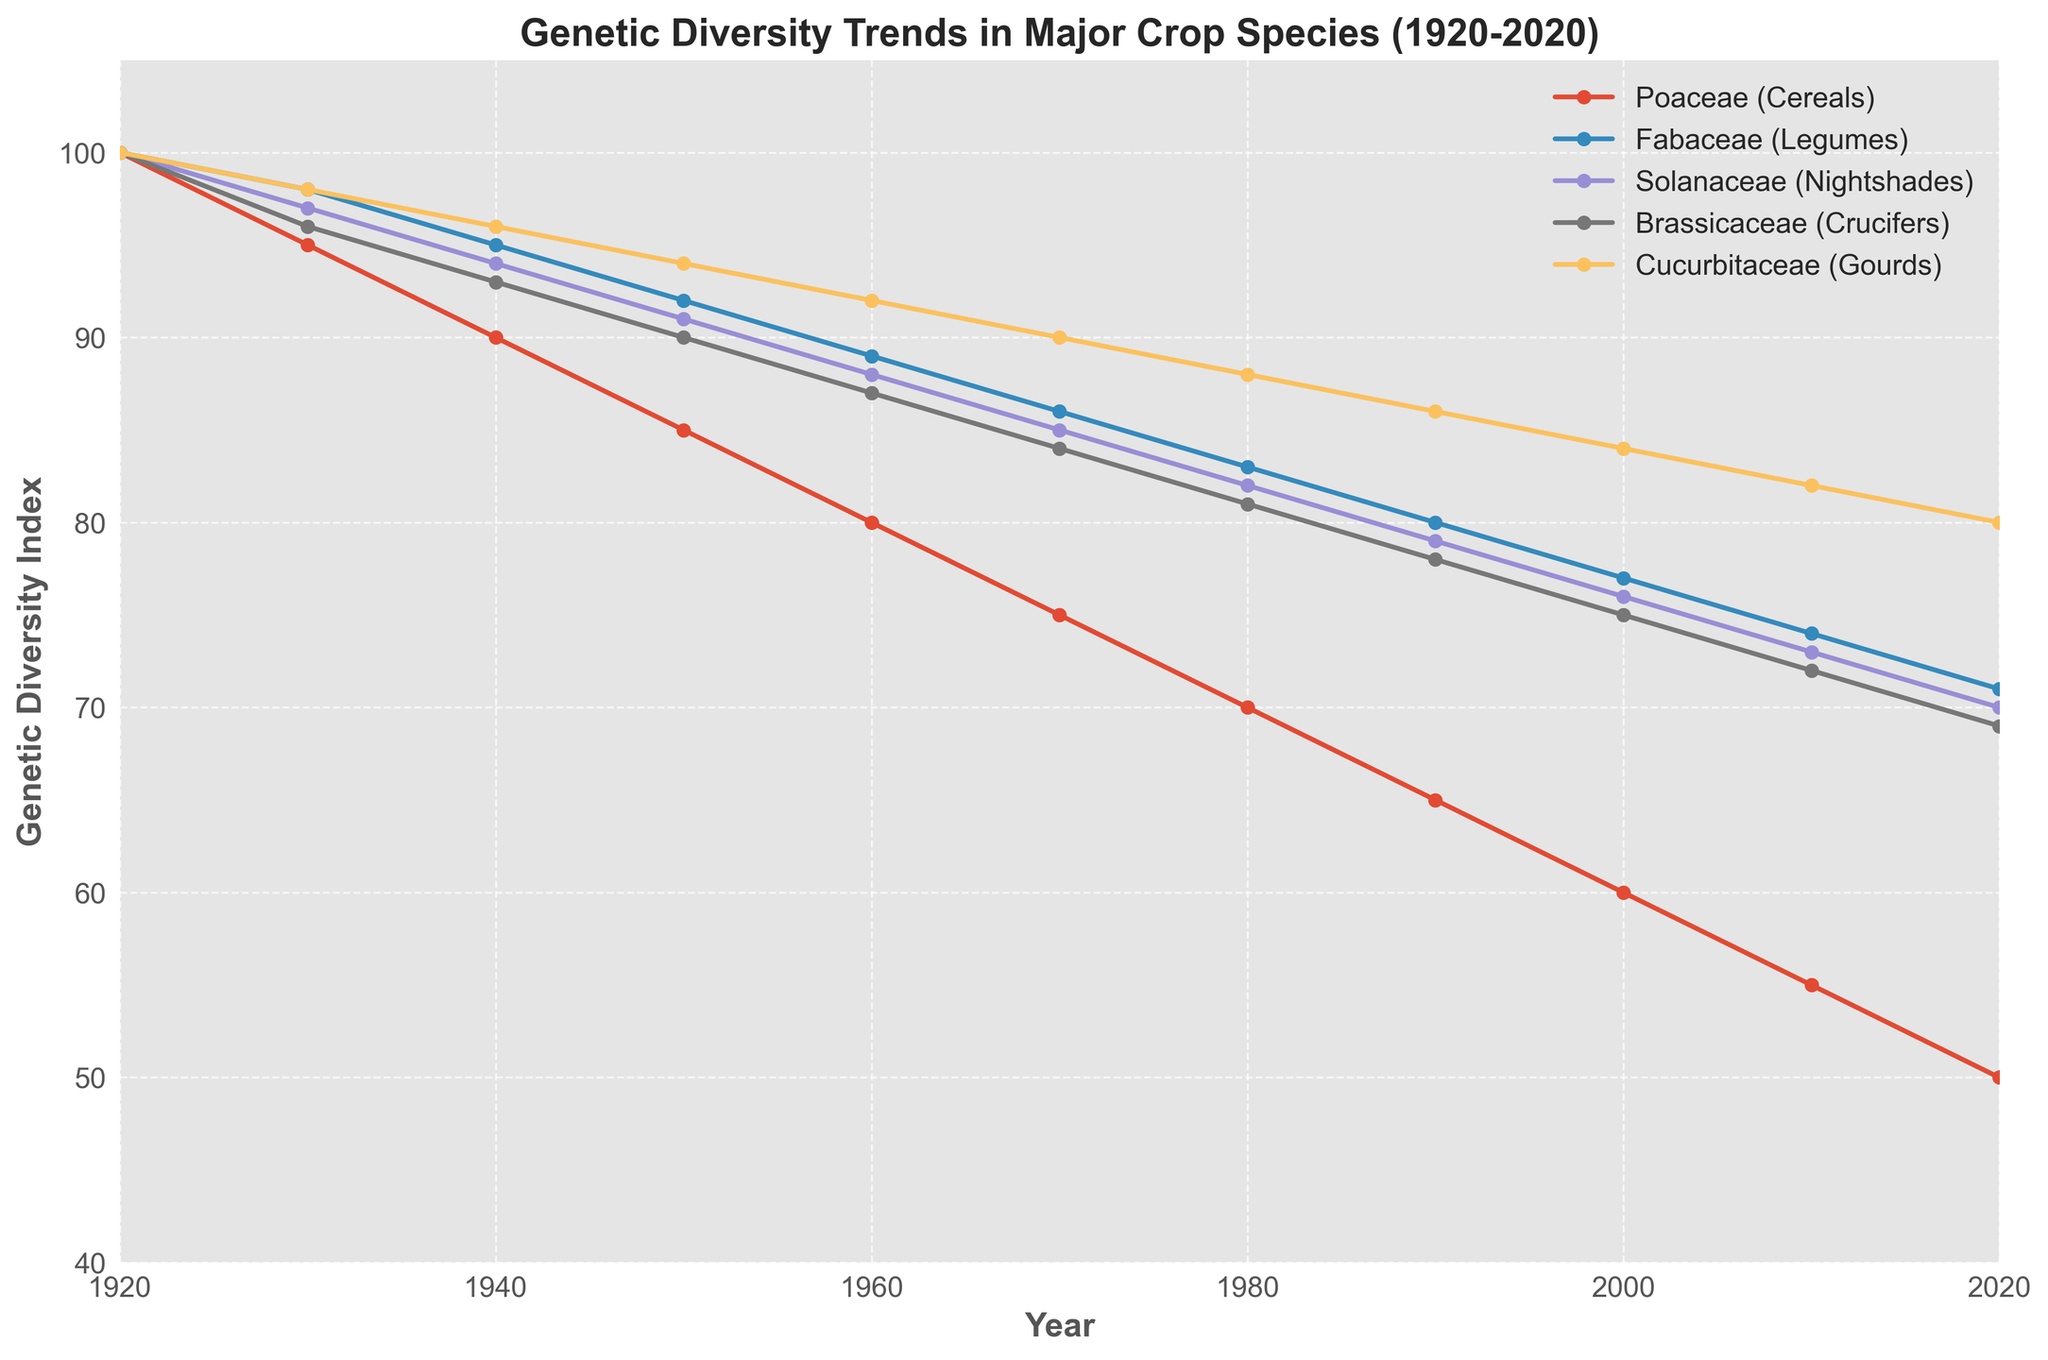Which crop family shows the greatest reduction in genetic diversity from 1920 to 2020? To find the greatest reduction, we look for the crop family with the highest decrease in genetic diversity index from 1920 to 2020. The Poaceae (Cereals) family goes from 100 to 50, which is a reduction of 50, the highest among all families.
Answer: Poaceae (Cereals) In what decade does the Fabaceae (Legumes) family first fall below a genetic diversity index of 90? We look at the trend line for the Fabaceae (Legumes) family and identify the first point below 90. This occurs in the 1960s, where the index is 89.
Answer: 1960s Which crop family maintained the highest genetic diversity index in 2020? To determine this, check the index values in 2020 and identify the highest value. Cucurbitaceae (Gourds) has the highest index at 80.
Answer: Cucurbitaceae (Gourds) By how much did the genetic diversity index of Solanaceae (Nightshades) change from 1950 to 2000? Find the index values for Solanaceae (Nightshades) in 1950 (91) and in 2000 (76) and calculate the difference: 91 - 76 = 15.
Answer: 15 Compare the genetic diversity indices of Brassicaceae (Crucifers) and Cucurbitaceae (Gourds) in 1940. Which family has a higher index and by how much? Check the indices in 1940: Brassicaceae (Crucifers) is 93 and Cucurbitaceae (Gourds) is 96. Cucurbitaceae is higher by 96 - 93 = 3.
Answer: Cucurbitaceae (Gourds) by 3 What is the average genetic diversity index of the Poaceae (Cereals) family in the years 1920, 1950, and 1980? Find the values for these years: 1920 (100), 1950 (85), and 1980 (70). The average is (100 + 85 + 70) / 3 = 255 / 3 = 85.
Answer: 85 Which decade saw the smallest change in genetic diversity for Brassicaceae (Crucifers)? Analyze decade-by-decade changes: The smallest change is from 1940 to 1950, where the decrease is 3 (94 to 91).
Answer: 1940s Are there any decades where the genetic diversity index of one crop family remained constant? Observe the trend lines for all families. All lines show a steady decline with no constant decades.
Answer: No 